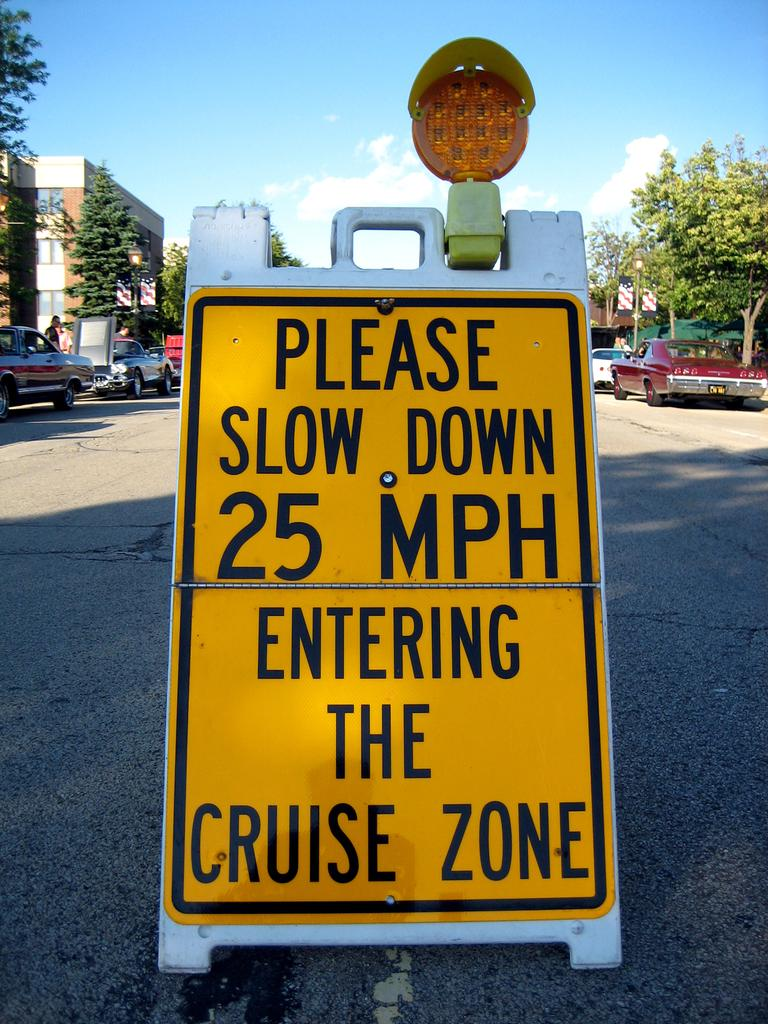<image>
Provide a brief description of the given image. A yellow road signs reads "please slow down 25mph entering the cruise zone" 